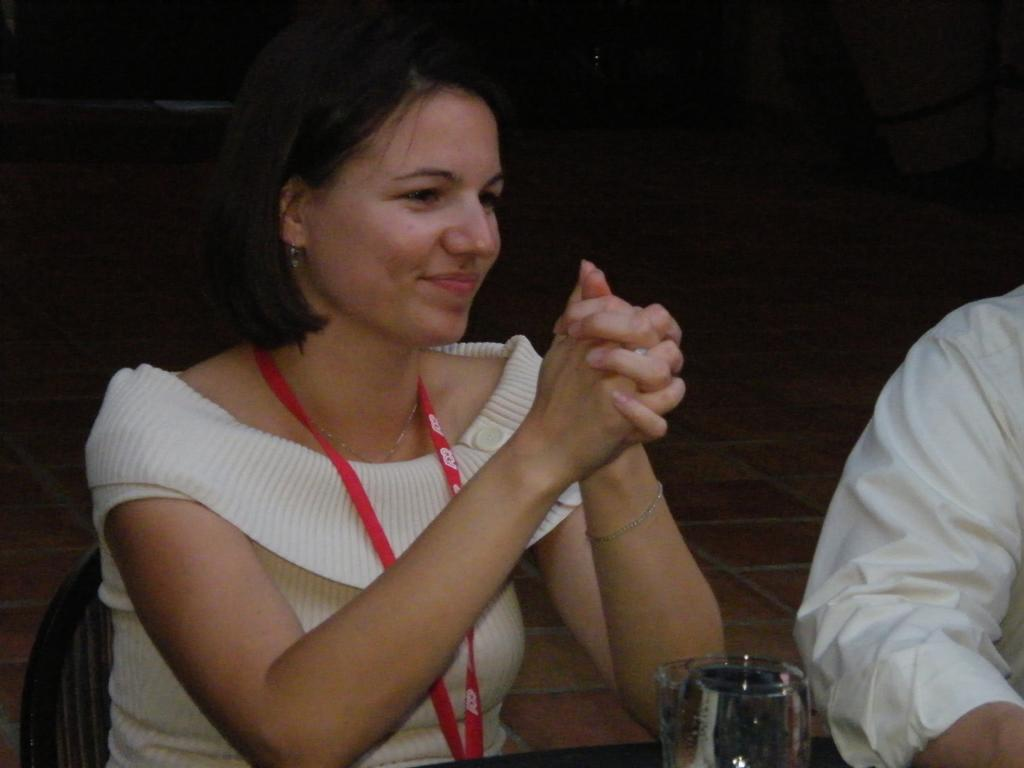How many people are in the image? There are two persons in the image. What are the persons doing in the image? The persons are sitting on chairs. What is present on the table in the image? There is a glass on the table. What can be seen in the background of the image? The background of the image is dark. What type of pipe can be seen in the image? There is no pipe present in the image. Is there a recess in the wall behind the persons in the image? The image does not provide information about the wall behind the persons, so it cannot be determined if there is a recess. Can you tell me how many times the persons in the image have used the lift today? There is no lift present in the image, so it cannot be determined how many times the persons have used it. 